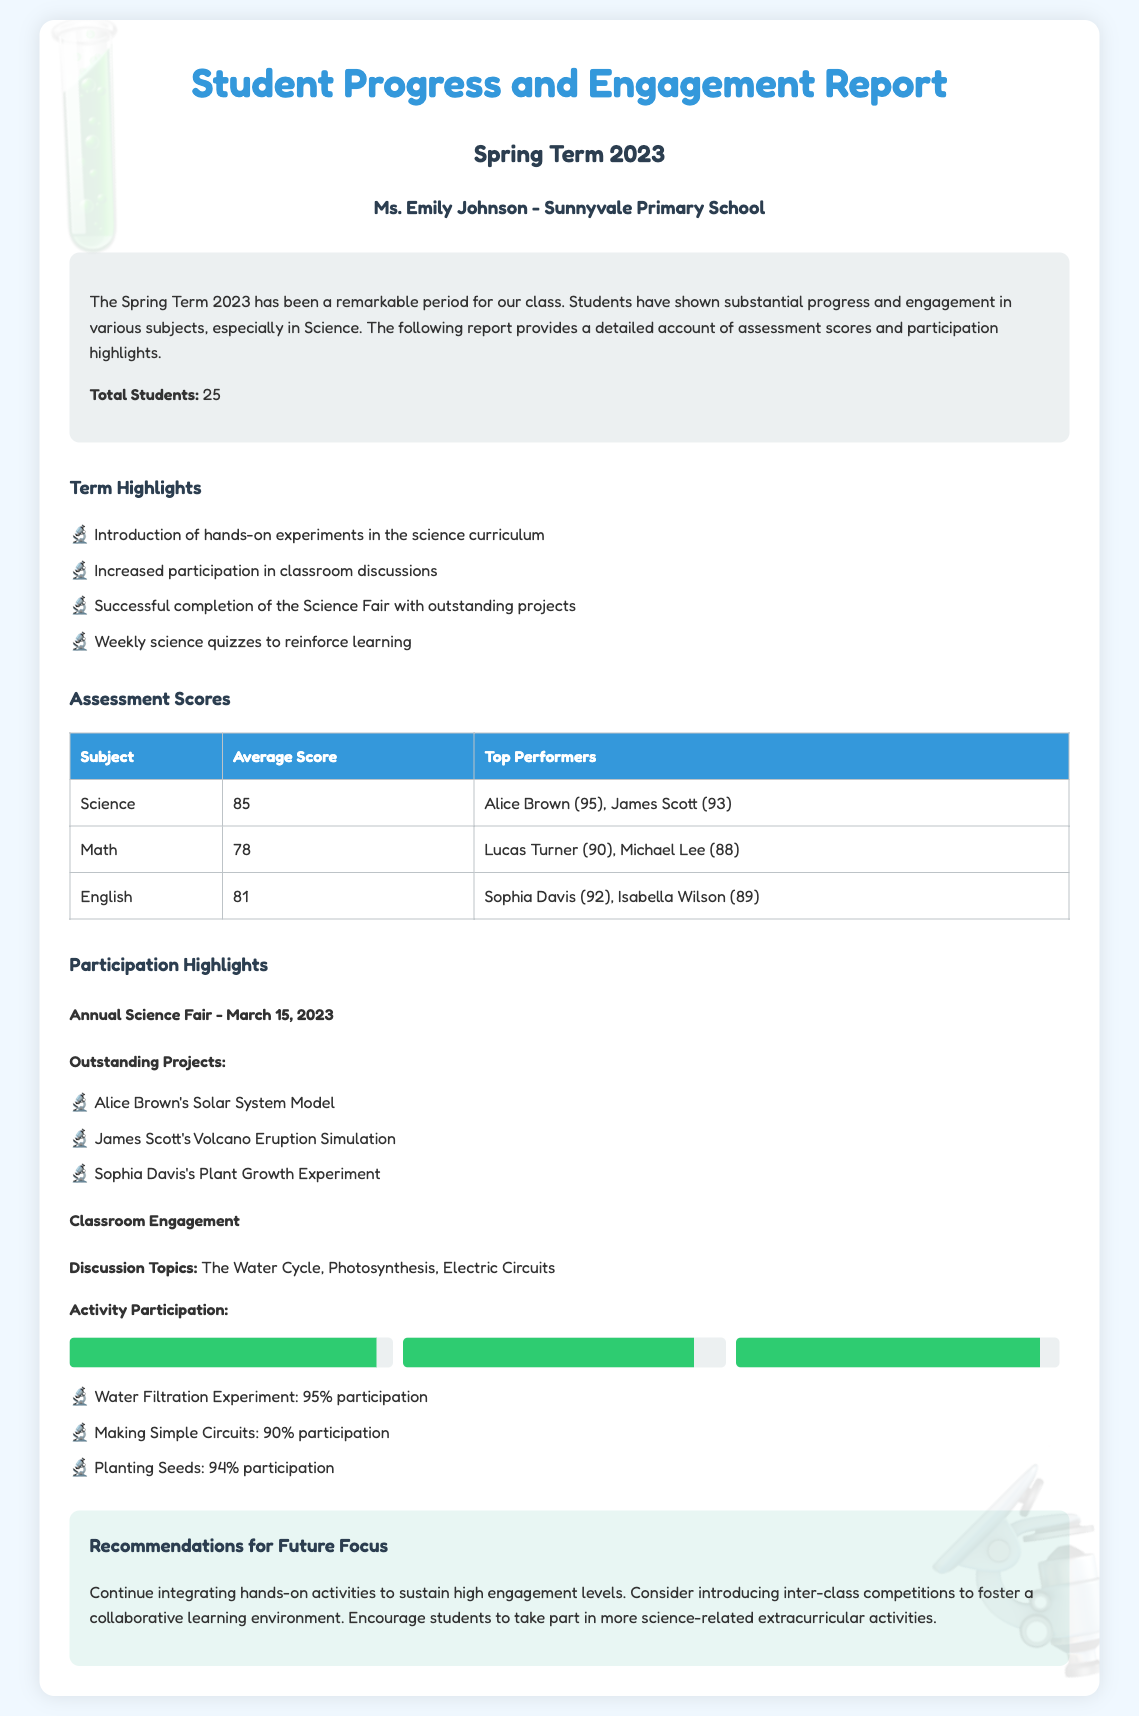What is the average score in Science? The average score in Science is listed in the assessment scores table.
Answer: 85 Who is the top performer in English? The top performer in English is mentioned in the assessment scores table.
Answer: Sophia Davis How many total students are there? The total number of students is stated in the summary section.
Answer: 25 What was the participation percentage for the Water Filtration Experiment? The participation percentage for the Water Filtration Experiment is given in the participation highlights.
Answer: 95% What subject had the lowest average score? The subject with the lowest average score can be derived from the assessment scores table.
Answer: Math What significant event occurred on March 15, 2023? The event that occurred on March 15, 2023 is noted under participation highlights.
Answer: Annual Science Fair Which student created a Solar System Model? The student who created a Solar System Model is listed among the outstanding projects.
Answer: Alice Brown What are the recommended future focuses for the class? The recommendations for future focus are provided in the recommendations section.
Answer: Integrating hands-on activities What percentage of participation was recorded for making simple circuits? The percentage of participation for making simple circuits is detailed in the participation highlights.
Answer: 90% 